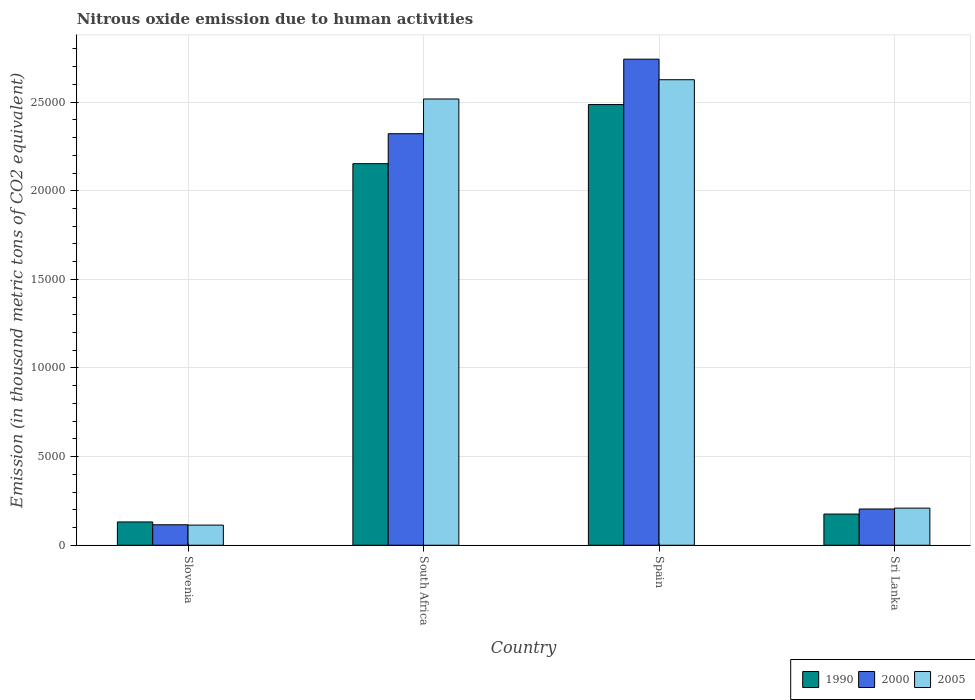Are the number of bars per tick equal to the number of legend labels?
Offer a very short reply. Yes. Are the number of bars on each tick of the X-axis equal?
Keep it short and to the point. Yes. How many bars are there on the 3rd tick from the right?
Make the answer very short. 3. What is the label of the 1st group of bars from the left?
Provide a short and direct response. Slovenia. What is the amount of nitrous oxide emitted in 2000 in Slovenia?
Keep it short and to the point. 1154.3. Across all countries, what is the maximum amount of nitrous oxide emitted in 2005?
Give a very brief answer. 2.63e+04. Across all countries, what is the minimum amount of nitrous oxide emitted in 1990?
Offer a terse response. 1313.9. In which country was the amount of nitrous oxide emitted in 2000 minimum?
Your answer should be very brief. Slovenia. What is the total amount of nitrous oxide emitted in 2000 in the graph?
Offer a very short reply. 5.38e+04. What is the difference between the amount of nitrous oxide emitted in 1990 in Slovenia and that in Sri Lanka?
Offer a very short reply. -445.5. What is the difference between the amount of nitrous oxide emitted in 2005 in Sri Lanka and the amount of nitrous oxide emitted in 2000 in Slovenia?
Offer a very short reply. 939.8. What is the average amount of nitrous oxide emitted in 2005 per country?
Ensure brevity in your answer.  1.37e+04. What is the difference between the amount of nitrous oxide emitted of/in 2005 and amount of nitrous oxide emitted of/in 1990 in Sri Lanka?
Give a very brief answer. 334.7. In how many countries, is the amount of nitrous oxide emitted in 2000 greater than 9000 thousand metric tons?
Make the answer very short. 2. What is the ratio of the amount of nitrous oxide emitted in 2000 in Slovenia to that in South Africa?
Your answer should be very brief. 0.05. Is the amount of nitrous oxide emitted in 2000 in South Africa less than that in Sri Lanka?
Offer a very short reply. No. What is the difference between the highest and the second highest amount of nitrous oxide emitted in 2005?
Your response must be concise. 2.31e+04. What is the difference between the highest and the lowest amount of nitrous oxide emitted in 2000?
Offer a terse response. 2.63e+04. In how many countries, is the amount of nitrous oxide emitted in 2005 greater than the average amount of nitrous oxide emitted in 2005 taken over all countries?
Keep it short and to the point. 2. Is the sum of the amount of nitrous oxide emitted in 1990 in Slovenia and Spain greater than the maximum amount of nitrous oxide emitted in 2000 across all countries?
Keep it short and to the point. No. How many bars are there?
Provide a short and direct response. 12. What is the difference between two consecutive major ticks on the Y-axis?
Offer a terse response. 5000. Are the values on the major ticks of Y-axis written in scientific E-notation?
Your answer should be compact. No. Does the graph contain any zero values?
Make the answer very short. No. Does the graph contain grids?
Give a very brief answer. Yes. Where does the legend appear in the graph?
Your answer should be very brief. Bottom right. How many legend labels are there?
Provide a short and direct response. 3. What is the title of the graph?
Provide a short and direct response. Nitrous oxide emission due to human activities. Does "1997" appear as one of the legend labels in the graph?
Provide a succinct answer. No. What is the label or title of the Y-axis?
Offer a very short reply. Emission (in thousand metric tons of CO2 equivalent). What is the Emission (in thousand metric tons of CO2 equivalent) of 1990 in Slovenia?
Ensure brevity in your answer.  1313.9. What is the Emission (in thousand metric tons of CO2 equivalent) in 2000 in Slovenia?
Provide a succinct answer. 1154.3. What is the Emission (in thousand metric tons of CO2 equivalent) in 2005 in Slovenia?
Make the answer very short. 1135.7. What is the Emission (in thousand metric tons of CO2 equivalent) of 1990 in South Africa?
Provide a short and direct response. 2.15e+04. What is the Emission (in thousand metric tons of CO2 equivalent) in 2000 in South Africa?
Offer a very short reply. 2.32e+04. What is the Emission (in thousand metric tons of CO2 equivalent) in 2005 in South Africa?
Give a very brief answer. 2.52e+04. What is the Emission (in thousand metric tons of CO2 equivalent) of 1990 in Spain?
Your answer should be very brief. 2.49e+04. What is the Emission (in thousand metric tons of CO2 equivalent) of 2000 in Spain?
Offer a terse response. 2.74e+04. What is the Emission (in thousand metric tons of CO2 equivalent) of 2005 in Spain?
Your response must be concise. 2.63e+04. What is the Emission (in thousand metric tons of CO2 equivalent) in 1990 in Sri Lanka?
Offer a terse response. 1759.4. What is the Emission (in thousand metric tons of CO2 equivalent) in 2000 in Sri Lanka?
Provide a succinct answer. 2044.5. What is the Emission (in thousand metric tons of CO2 equivalent) in 2005 in Sri Lanka?
Offer a very short reply. 2094.1. Across all countries, what is the maximum Emission (in thousand metric tons of CO2 equivalent) in 1990?
Ensure brevity in your answer.  2.49e+04. Across all countries, what is the maximum Emission (in thousand metric tons of CO2 equivalent) of 2000?
Your answer should be very brief. 2.74e+04. Across all countries, what is the maximum Emission (in thousand metric tons of CO2 equivalent) in 2005?
Your answer should be very brief. 2.63e+04. Across all countries, what is the minimum Emission (in thousand metric tons of CO2 equivalent) of 1990?
Ensure brevity in your answer.  1313.9. Across all countries, what is the minimum Emission (in thousand metric tons of CO2 equivalent) in 2000?
Ensure brevity in your answer.  1154.3. Across all countries, what is the minimum Emission (in thousand metric tons of CO2 equivalent) of 2005?
Your response must be concise. 1135.7. What is the total Emission (in thousand metric tons of CO2 equivalent) in 1990 in the graph?
Provide a succinct answer. 4.95e+04. What is the total Emission (in thousand metric tons of CO2 equivalent) in 2000 in the graph?
Offer a terse response. 5.38e+04. What is the total Emission (in thousand metric tons of CO2 equivalent) in 2005 in the graph?
Offer a terse response. 5.47e+04. What is the difference between the Emission (in thousand metric tons of CO2 equivalent) of 1990 in Slovenia and that in South Africa?
Provide a succinct answer. -2.02e+04. What is the difference between the Emission (in thousand metric tons of CO2 equivalent) in 2000 in Slovenia and that in South Africa?
Your response must be concise. -2.21e+04. What is the difference between the Emission (in thousand metric tons of CO2 equivalent) in 2005 in Slovenia and that in South Africa?
Offer a terse response. -2.40e+04. What is the difference between the Emission (in thousand metric tons of CO2 equivalent) in 1990 in Slovenia and that in Spain?
Provide a short and direct response. -2.35e+04. What is the difference between the Emission (in thousand metric tons of CO2 equivalent) of 2000 in Slovenia and that in Spain?
Your answer should be very brief. -2.63e+04. What is the difference between the Emission (in thousand metric tons of CO2 equivalent) of 2005 in Slovenia and that in Spain?
Your response must be concise. -2.51e+04. What is the difference between the Emission (in thousand metric tons of CO2 equivalent) of 1990 in Slovenia and that in Sri Lanka?
Ensure brevity in your answer.  -445.5. What is the difference between the Emission (in thousand metric tons of CO2 equivalent) in 2000 in Slovenia and that in Sri Lanka?
Provide a succinct answer. -890.2. What is the difference between the Emission (in thousand metric tons of CO2 equivalent) in 2005 in Slovenia and that in Sri Lanka?
Provide a succinct answer. -958.4. What is the difference between the Emission (in thousand metric tons of CO2 equivalent) of 1990 in South Africa and that in Spain?
Your response must be concise. -3335.2. What is the difference between the Emission (in thousand metric tons of CO2 equivalent) in 2000 in South Africa and that in Spain?
Offer a terse response. -4205.2. What is the difference between the Emission (in thousand metric tons of CO2 equivalent) in 2005 in South Africa and that in Spain?
Keep it short and to the point. -1086.5. What is the difference between the Emission (in thousand metric tons of CO2 equivalent) in 1990 in South Africa and that in Sri Lanka?
Ensure brevity in your answer.  1.98e+04. What is the difference between the Emission (in thousand metric tons of CO2 equivalent) in 2000 in South Africa and that in Sri Lanka?
Ensure brevity in your answer.  2.12e+04. What is the difference between the Emission (in thousand metric tons of CO2 equivalent) in 2005 in South Africa and that in Sri Lanka?
Give a very brief answer. 2.31e+04. What is the difference between the Emission (in thousand metric tons of CO2 equivalent) of 1990 in Spain and that in Sri Lanka?
Give a very brief answer. 2.31e+04. What is the difference between the Emission (in thousand metric tons of CO2 equivalent) in 2000 in Spain and that in Sri Lanka?
Provide a succinct answer. 2.54e+04. What is the difference between the Emission (in thousand metric tons of CO2 equivalent) in 2005 in Spain and that in Sri Lanka?
Provide a short and direct response. 2.42e+04. What is the difference between the Emission (in thousand metric tons of CO2 equivalent) of 1990 in Slovenia and the Emission (in thousand metric tons of CO2 equivalent) of 2000 in South Africa?
Ensure brevity in your answer.  -2.19e+04. What is the difference between the Emission (in thousand metric tons of CO2 equivalent) in 1990 in Slovenia and the Emission (in thousand metric tons of CO2 equivalent) in 2005 in South Africa?
Keep it short and to the point. -2.39e+04. What is the difference between the Emission (in thousand metric tons of CO2 equivalent) in 2000 in Slovenia and the Emission (in thousand metric tons of CO2 equivalent) in 2005 in South Africa?
Your response must be concise. -2.40e+04. What is the difference between the Emission (in thousand metric tons of CO2 equivalent) of 1990 in Slovenia and the Emission (in thousand metric tons of CO2 equivalent) of 2000 in Spain?
Provide a short and direct response. -2.61e+04. What is the difference between the Emission (in thousand metric tons of CO2 equivalent) in 1990 in Slovenia and the Emission (in thousand metric tons of CO2 equivalent) in 2005 in Spain?
Provide a succinct answer. -2.49e+04. What is the difference between the Emission (in thousand metric tons of CO2 equivalent) of 2000 in Slovenia and the Emission (in thousand metric tons of CO2 equivalent) of 2005 in Spain?
Your answer should be compact. -2.51e+04. What is the difference between the Emission (in thousand metric tons of CO2 equivalent) in 1990 in Slovenia and the Emission (in thousand metric tons of CO2 equivalent) in 2000 in Sri Lanka?
Give a very brief answer. -730.6. What is the difference between the Emission (in thousand metric tons of CO2 equivalent) in 1990 in Slovenia and the Emission (in thousand metric tons of CO2 equivalent) in 2005 in Sri Lanka?
Keep it short and to the point. -780.2. What is the difference between the Emission (in thousand metric tons of CO2 equivalent) in 2000 in Slovenia and the Emission (in thousand metric tons of CO2 equivalent) in 2005 in Sri Lanka?
Keep it short and to the point. -939.8. What is the difference between the Emission (in thousand metric tons of CO2 equivalent) of 1990 in South Africa and the Emission (in thousand metric tons of CO2 equivalent) of 2000 in Spain?
Your response must be concise. -5895.5. What is the difference between the Emission (in thousand metric tons of CO2 equivalent) of 1990 in South Africa and the Emission (in thousand metric tons of CO2 equivalent) of 2005 in Spain?
Provide a succinct answer. -4735.9. What is the difference between the Emission (in thousand metric tons of CO2 equivalent) in 2000 in South Africa and the Emission (in thousand metric tons of CO2 equivalent) in 2005 in Spain?
Keep it short and to the point. -3045.6. What is the difference between the Emission (in thousand metric tons of CO2 equivalent) of 1990 in South Africa and the Emission (in thousand metric tons of CO2 equivalent) of 2000 in Sri Lanka?
Your response must be concise. 1.95e+04. What is the difference between the Emission (in thousand metric tons of CO2 equivalent) in 1990 in South Africa and the Emission (in thousand metric tons of CO2 equivalent) in 2005 in Sri Lanka?
Offer a terse response. 1.94e+04. What is the difference between the Emission (in thousand metric tons of CO2 equivalent) of 2000 in South Africa and the Emission (in thousand metric tons of CO2 equivalent) of 2005 in Sri Lanka?
Give a very brief answer. 2.11e+04. What is the difference between the Emission (in thousand metric tons of CO2 equivalent) of 1990 in Spain and the Emission (in thousand metric tons of CO2 equivalent) of 2000 in Sri Lanka?
Ensure brevity in your answer.  2.28e+04. What is the difference between the Emission (in thousand metric tons of CO2 equivalent) of 1990 in Spain and the Emission (in thousand metric tons of CO2 equivalent) of 2005 in Sri Lanka?
Your answer should be compact. 2.28e+04. What is the difference between the Emission (in thousand metric tons of CO2 equivalent) of 2000 in Spain and the Emission (in thousand metric tons of CO2 equivalent) of 2005 in Sri Lanka?
Your answer should be compact. 2.53e+04. What is the average Emission (in thousand metric tons of CO2 equivalent) in 1990 per country?
Provide a short and direct response. 1.24e+04. What is the average Emission (in thousand metric tons of CO2 equivalent) in 2000 per country?
Your answer should be compact. 1.35e+04. What is the average Emission (in thousand metric tons of CO2 equivalent) in 2005 per country?
Ensure brevity in your answer.  1.37e+04. What is the difference between the Emission (in thousand metric tons of CO2 equivalent) in 1990 and Emission (in thousand metric tons of CO2 equivalent) in 2000 in Slovenia?
Offer a terse response. 159.6. What is the difference between the Emission (in thousand metric tons of CO2 equivalent) in 1990 and Emission (in thousand metric tons of CO2 equivalent) in 2005 in Slovenia?
Provide a succinct answer. 178.2. What is the difference between the Emission (in thousand metric tons of CO2 equivalent) of 2000 and Emission (in thousand metric tons of CO2 equivalent) of 2005 in Slovenia?
Your response must be concise. 18.6. What is the difference between the Emission (in thousand metric tons of CO2 equivalent) in 1990 and Emission (in thousand metric tons of CO2 equivalent) in 2000 in South Africa?
Your answer should be compact. -1690.3. What is the difference between the Emission (in thousand metric tons of CO2 equivalent) in 1990 and Emission (in thousand metric tons of CO2 equivalent) in 2005 in South Africa?
Ensure brevity in your answer.  -3649.4. What is the difference between the Emission (in thousand metric tons of CO2 equivalent) in 2000 and Emission (in thousand metric tons of CO2 equivalent) in 2005 in South Africa?
Make the answer very short. -1959.1. What is the difference between the Emission (in thousand metric tons of CO2 equivalent) in 1990 and Emission (in thousand metric tons of CO2 equivalent) in 2000 in Spain?
Provide a succinct answer. -2560.3. What is the difference between the Emission (in thousand metric tons of CO2 equivalent) of 1990 and Emission (in thousand metric tons of CO2 equivalent) of 2005 in Spain?
Provide a short and direct response. -1400.7. What is the difference between the Emission (in thousand metric tons of CO2 equivalent) of 2000 and Emission (in thousand metric tons of CO2 equivalent) of 2005 in Spain?
Your answer should be compact. 1159.6. What is the difference between the Emission (in thousand metric tons of CO2 equivalent) of 1990 and Emission (in thousand metric tons of CO2 equivalent) of 2000 in Sri Lanka?
Your response must be concise. -285.1. What is the difference between the Emission (in thousand metric tons of CO2 equivalent) in 1990 and Emission (in thousand metric tons of CO2 equivalent) in 2005 in Sri Lanka?
Give a very brief answer. -334.7. What is the difference between the Emission (in thousand metric tons of CO2 equivalent) in 2000 and Emission (in thousand metric tons of CO2 equivalent) in 2005 in Sri Lanka?
Keep it short and to the point. -49.6. What is the ratio of the Emission (in thousand metric tons of CO2 equivalent) of 1990 in Slovenia to that in South Africa?
Offer a terse response. 0.06. What is the ratio of the Emission (in thousand metric tons of CO2 equivalent) of 2000 in Slovenia to that in South Africa?
Offer a very short reply. 0.05. What is the ratio of the Emission (in thousand metric tons of CO2 equivalent) of 2005 in Slovenia to that in South Africa?
Ensure brevity in your answer.  0.05. What is the ratio of the Emission (in thousand metric tons of CO2 equivalent) of 1990 in Slovenia to that in Spain?
Ensure brevity in your answer.  0.05. What is the ratio of the Emission (in thousand metric tons of CO2 equivalent) of 2000 in Slovenia to that in Spain?
Your answer should be compact. 0.04. What is the ratio of the Emission (in thousand metric tons of CO2 equivalent) in 2005 in Slovenia to that in Spain?
Your response must be concise. 0.04. What is the ratio of the Emission (in thousand metric tons of CO2 equivalent) of 1990 in Slovenia to that in Sri Lanka?
Make the answer very short. 0.75. What is the ratio of the Emission (in thousand metric tons of CO2 equivalent) in 2000 in Slovenia to that in Sri Lanka?
Give a very brief answer. 0.56. What is the ratio of the Emission (in thousand metric tons of CO2 equivalent) of 2005 in Slovenia to that in Sri Lanka?
Your answer should be compact. 0.54. What is the ratio of the Emission (in thousand metric tons of CO2 equivalent) in 1990 in South Africa to that in Spain?
Your response must be concise. 0.87. What is the ratio of the Emission (in thousand metric tons of CO2 equivalent) in 2000 in South Africa to that in Spain?
Give a very brief answer. 0.85. What is the ratio of the Emission (in thousand metric tons of CO2 equivalent) of 2005 in South Africa to that in Spain?
Your answer should be very brief. 0.96. What is the ratio of the Emission (in thousand metric tons of CO2 equivalent) in 1990 in South Africa to that in Sri Lanka?
Give a very brief answer. 12.24. What is the ratio of the Emission (in thousand metric tons of CO2 equivalent) of 2000 in South Africa to that in Sri Lanka?
Ensure brevity in your answer.  11.36. What is the ratio of the Emission (in thousand metric tons of CO2 equivalent) in 2005 in South Africa to that in Sri Lanka?
Provide a short and direct response. 12.02. What is the ratio of the Emission (in thousand metric tons of CO2 equivalent) in 1990 in Spain to that in Sri Lanka?
Your answer should be compact. 14.13. What is the ratio of the Emission (in thousand metric tons of CO2 equivalent) in 2000 in Spain to that in Sri Lanka?
Make the answer very short. 13.41. What is the ratio of the Emission (in thousand metric tons of CO2 equivalent) of 2005 in Spain to that in Sri Lanka?
Provide a short and direct response. 12.54. What is the difference between the highest and the second highest Emission (in thousand metric tons of CO2 equivalent) in 1990?
Give a very brief answer. 3335.2. What is the difference between the highest and the second highest Emission (in thousand metric tons of CO2 equivalent) in 2000?
Your answer should be very brief. 4205.2. What is the difference between the highest and the second highest Emission (in thousand metric tons of CO2 equivalent) in 2005?
Offer a terse response. 1086.5. What is the difference between the highest and the lowest Emission (in thousand metric tons of CO2 equivalent) of 1990?
Offer a very short reply. 2.35e+04. What is the difference between the highest and the lowest Emission (in thousand metric tons of CO2 equivalent) in 2000?
Offer a very short reply. 2.63e+04. What is the difference between the highest and the lowest Emission (in thousand metric tons of CO2 equivalent) of 2005?
Offer a very short reply. 2.51e+04. 